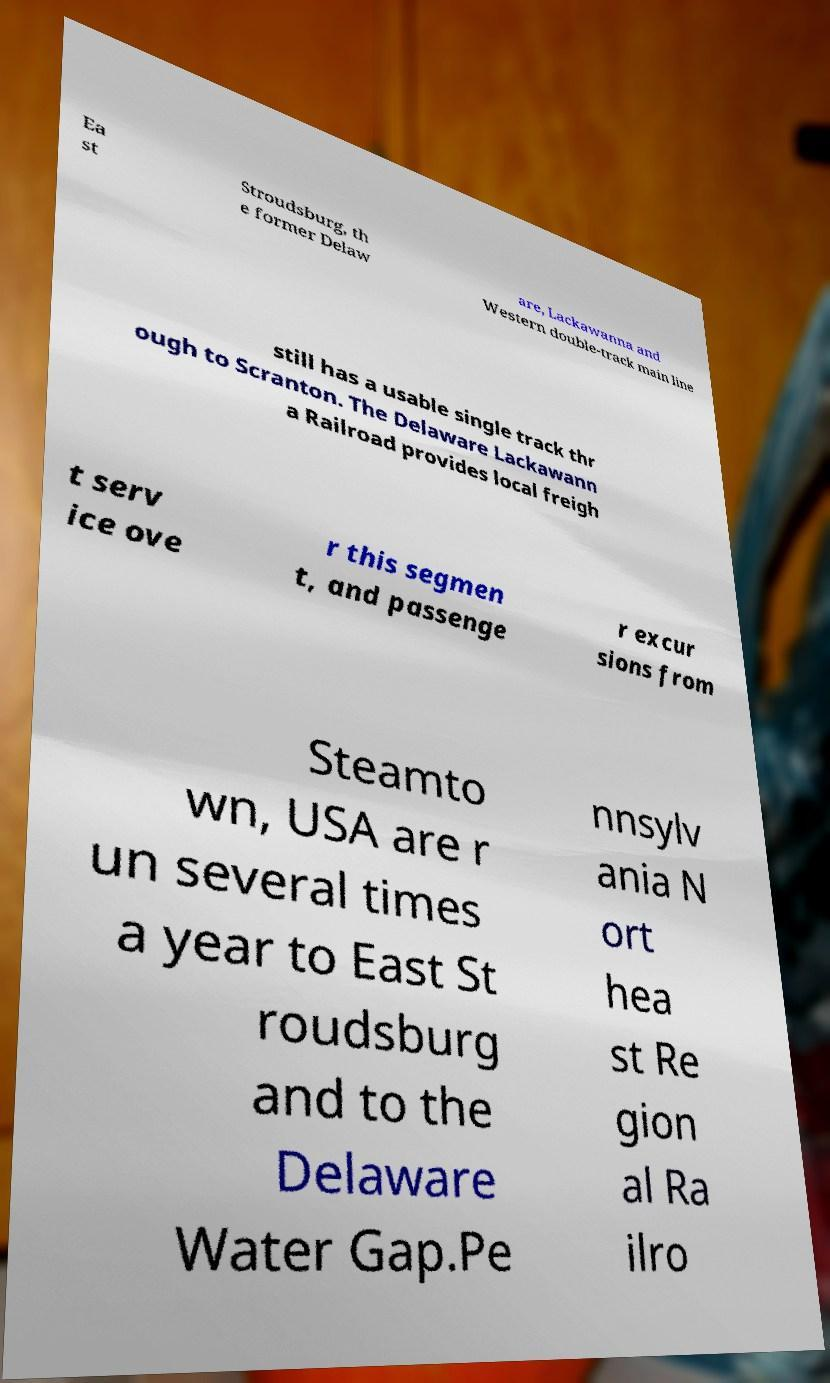I need the written content from this picture converted into text. Can you do that? Ea st Stroudsburg, th e former Delaw are, Lackawanna and Western double-track main line still has a usable single track thr ough to Scranton. The Delaware Lackawann a Railroad provides local freigh t serv ice ove r this segmen t, and passenge r excur sions from Steamto wn, USA are r un several times a year to East St roudsburg and to the Delaware Water Gap.Pe nnsylv ania N ort hea st Re gion al Ra ilro 